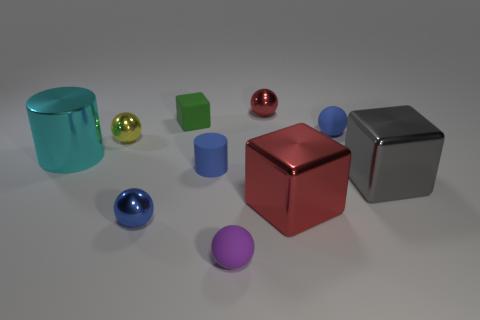Is the number of red objects greater than the number of metal things?
Provide a short and direct response. No. What number of objects are either spheres behind the small green matte block or small red objects?
Ensure brevity in your answer.  1. Is there another object of the same size as the yellow metal thing?
Your answer should be very brief. Yes. Are there fewer large red rubber blocks than cyan things?
Provide a succinct answer. Yes. How many balls are large cyan shiny things or large red objects?
Make the answer very short. 0. How many other cylinders are the same color as the tiny matte cylinder?
Keep it short and to the point. 0. There is a block that is both in front of the big cyan cylinder and to the left of the large gray thing; what is its size?
Your answer should be compact. Large. Are there fewer small yellow metallic objects that are left of the small yellow metallic object than small red metallic spheres?
Offer a very short reply. Yes. Is the blue cylinder made of the same material as the purple ball?
Your response must be concise. Yes. How many objects are either big red shiny cubes or large yellow metallic cubes?
Keep it short and to the point. 1. 